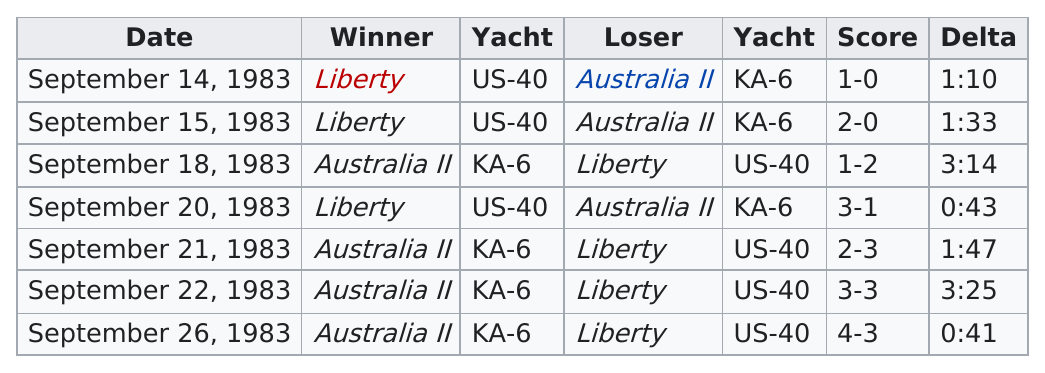Give some essential details in this illustration. The score in the top row is 1-0. The game with the shortest delta and highest score was played on September 26, 1983. Australia II is the winner that is listed last in the table. Australia II is the overall winner in the table, as stated. On September 15th, the score difference was 2. 